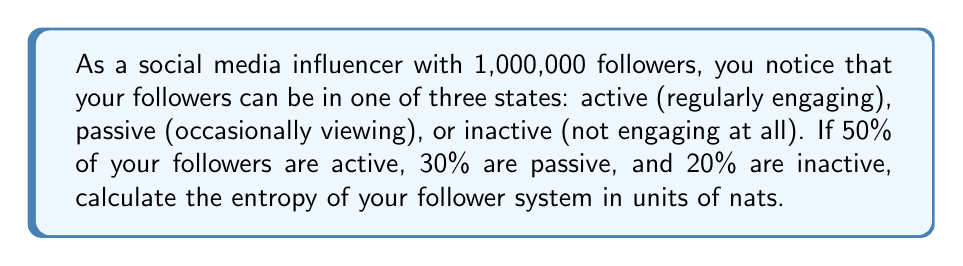What is the answer to this math problem? To calculate the entropy of the system, we'll use the formula for Shannon entropy:

$$S = -\sum_{i} p_i \ln(p_i)$$

Where $p_i$ is the probability of a follower being in state $i$.

Given:
- $p_1 = 0.50$ (active)
- $p_2 = 0.30$ (passive)
- $p_3 = 0.20$ (inactive)

Step 1: Calculate each term in the sum:
- $-p_1 \ln(p_1) = -0.50 \ln(0.50) = 0.3466$
- $-p_2 \ln(p_2) = -0.30 \ln(0.30) = 0.3611$
- $-p_3 \ln(p_3) = -0.20 \ln(0.20) = 0.3219$

Step 2: Sum all terms:
$$S = 0.3466 + 0.3611 + 0.3219 = 1.0296$$

The entropy is measured in nats because we used the natural logarithm.
Answer: 1.0296 nats 